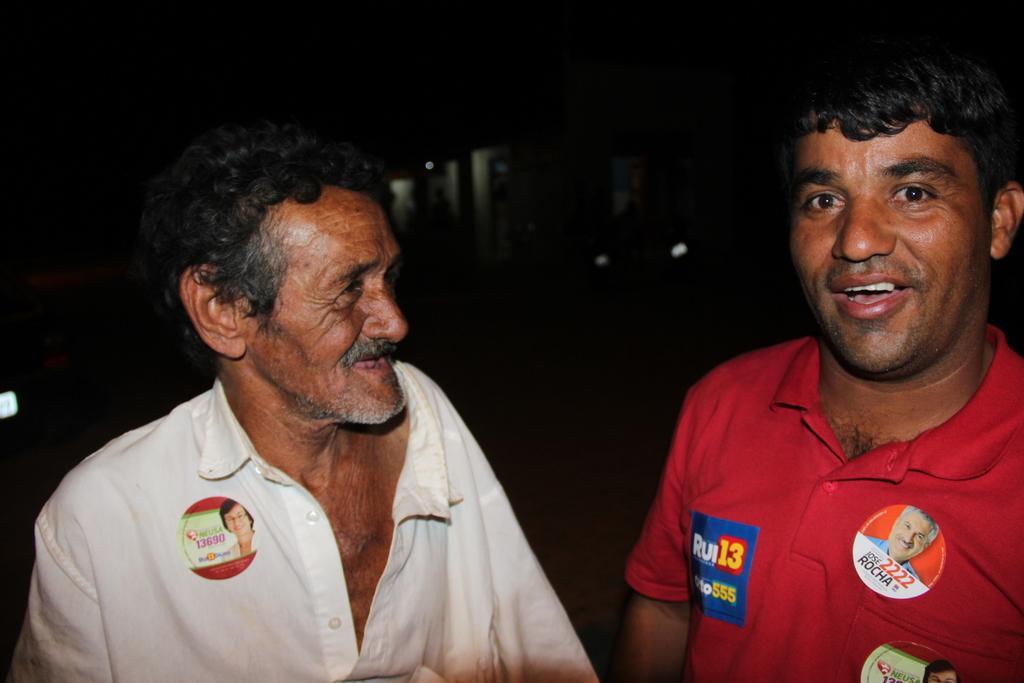Describe this image in one or two sentences. In this image, we can see people smiling. 